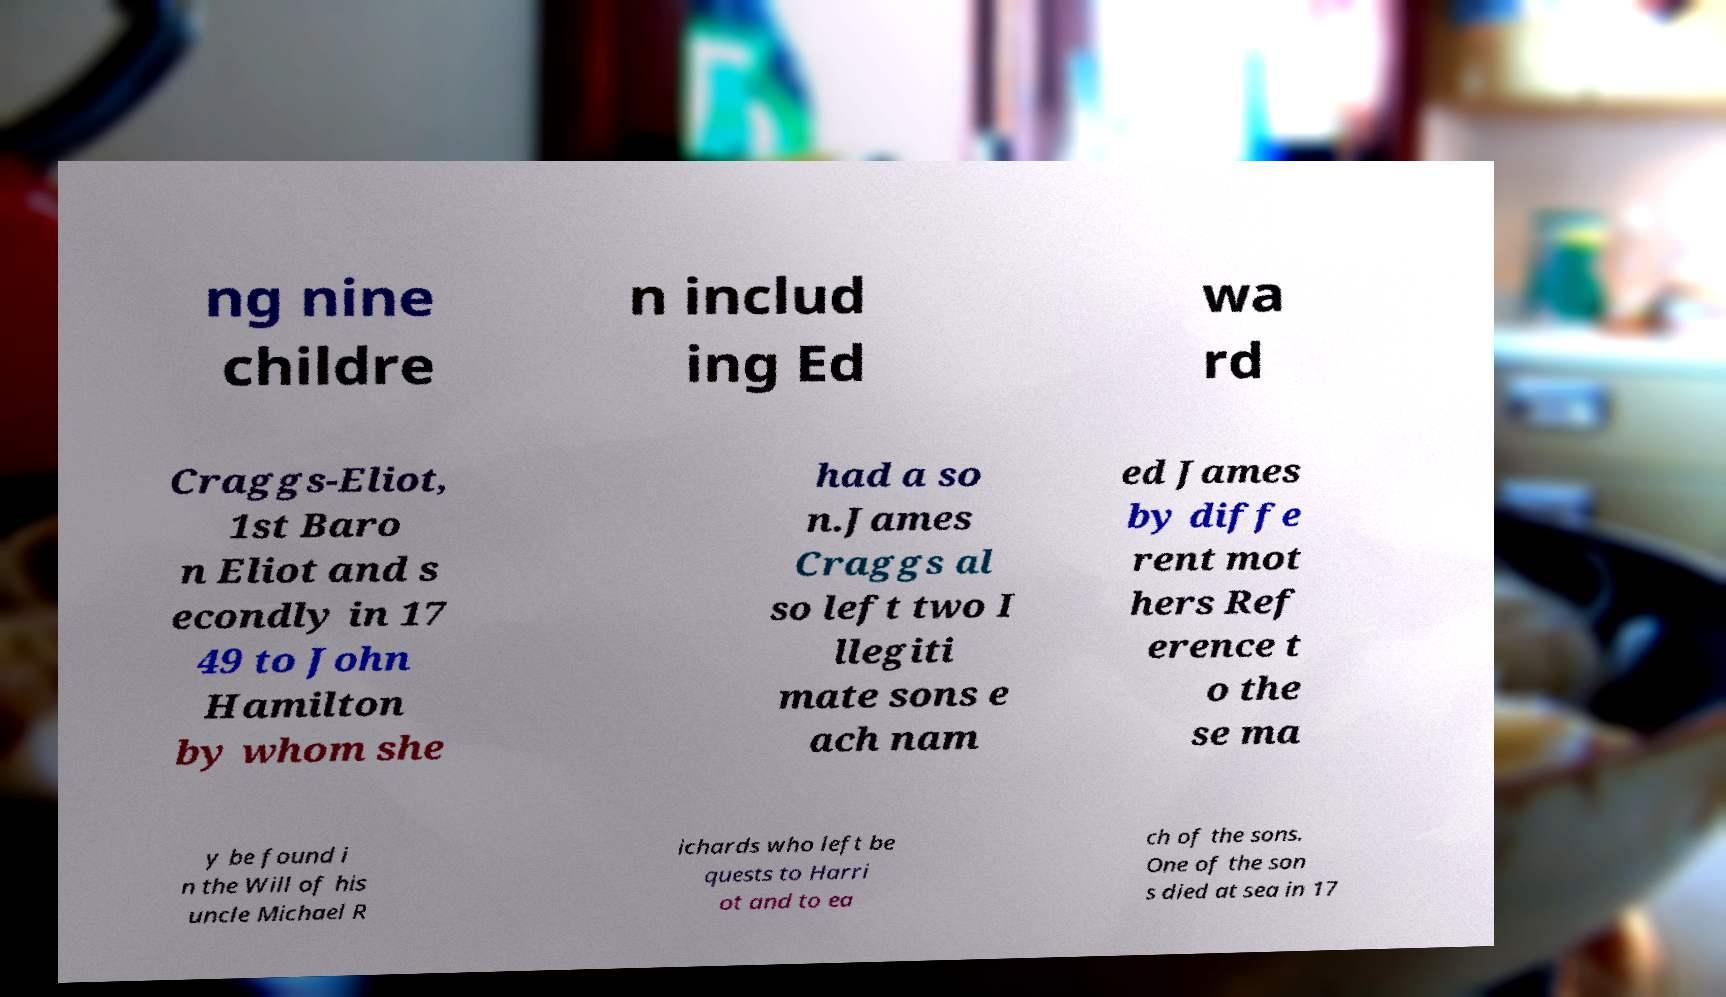What messages or text are displayed in this image? I need them in a readable, typed format. ng nine childre n includ ing Ed wa rd Craggs-Eliot, 1st Baro n Eliot and s econdly in 17 49 to John Hamilton by whom she had a so n.James Craggs al so left two I llegiti mate sons e ach nam ed James by diffe rent mot hers Ref erence t o the se ma y be found i n the Will of his uncle Michael R ichards who left be quests to Harri ot and to ea ch of the sons. One of the son s died at sea in 17 